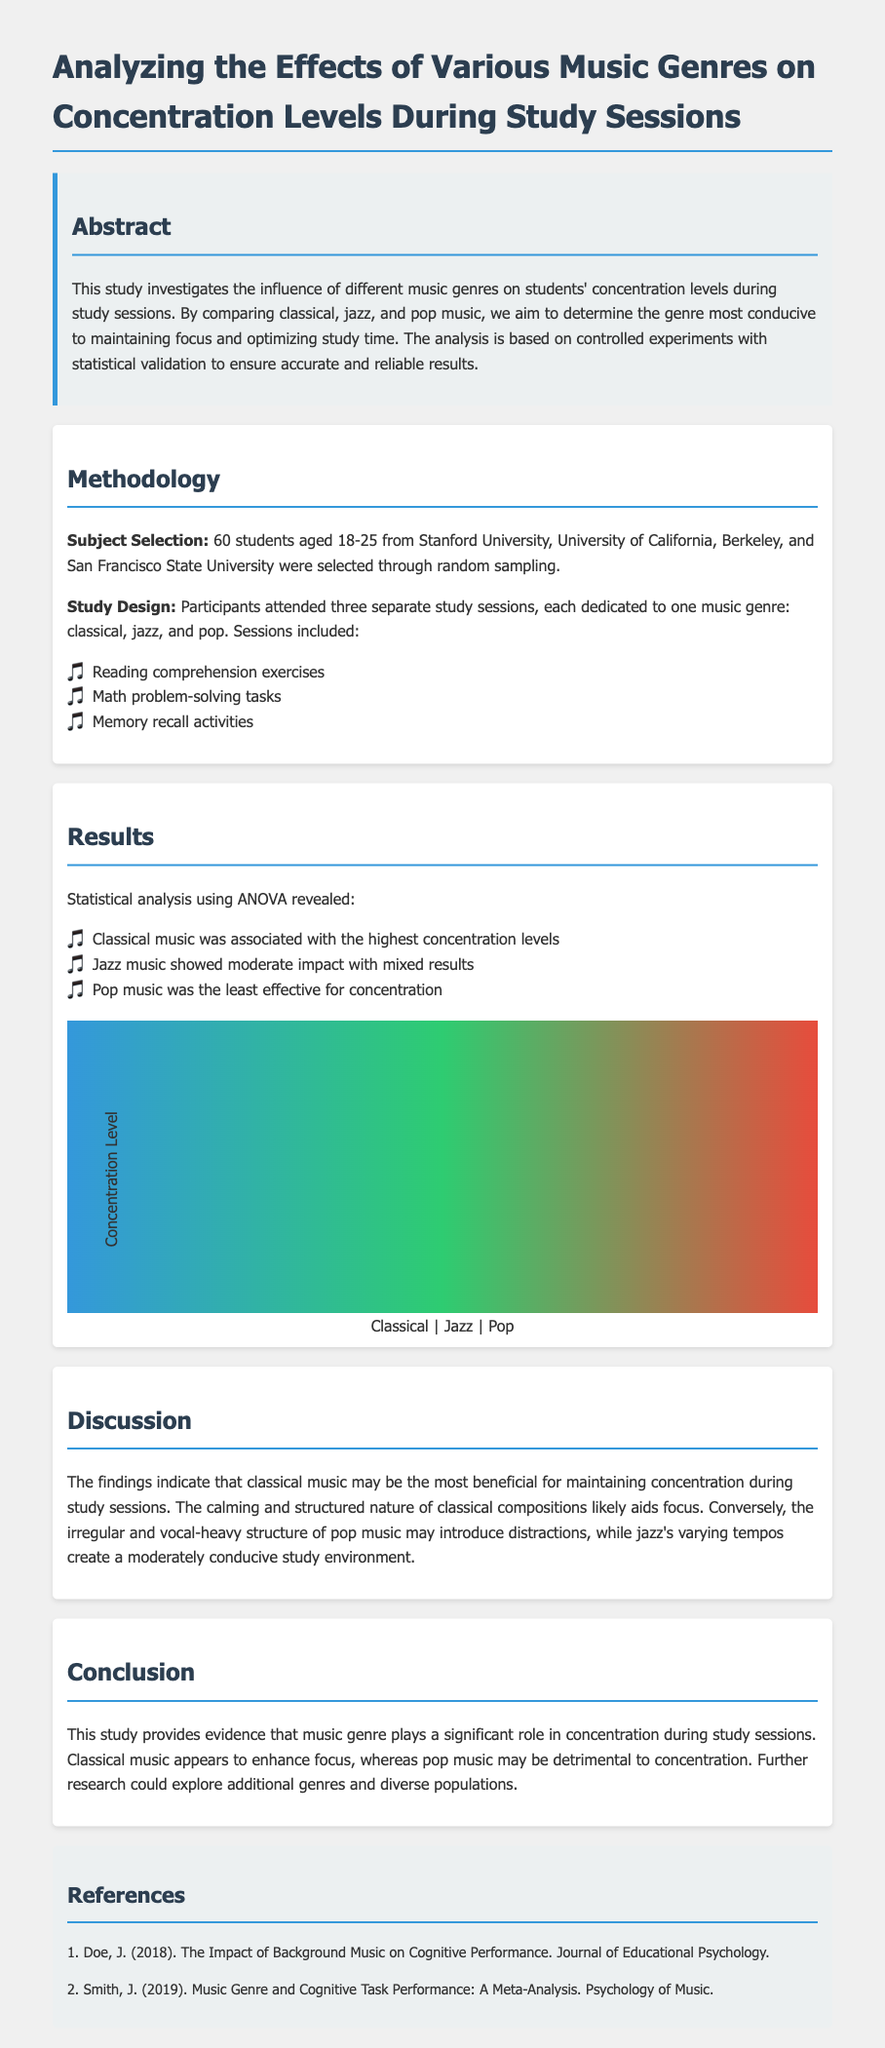What is the total number of subjects involved in the study? The total number of subjects is stated in the methodology section, which mentions 60 students were selected.
Answer: 60 students Which universities were involved in the subject selection? The document lists the universities from which the subjects were selected: Stanford University, University of California, Berkeley, and San Francisco State University.
Answer: Stanford University, University of California, Berkeley, San Francisco State University What statistical method was used to analyze the results? The results section specifies that ANOVA was used for statistical analysis.
Answer: ANOVA Which music genre showed the highest concentration levels? The results indicate that classical music was associated with the highest concentration levels.
Answer: Classical music What type of tasks were included in the study sessions? The methodology section includes reading comprehension exercises, math problem-solving tasks, and memory recall activities as the types of tasks.
Answer: Reading comprehension, math problems, memory recall Based on the study, what genre was considered least effective for concentration? The document states that pop music was the least effective for concentration during the study sessions.
Answer: Pop music What is the main conclusion drawn from the study? The conclusion emphasizes that classical music enhances focus while pop music may detract from concentration.
Answer: Classical music enhances focus, pop music detracts What is the primary objective of this study? The abstract mentions the objective is to investigate the influence of different music genres on students' concentration levels during study sessions.
Answer: Influence of different music genres on concentration levels 